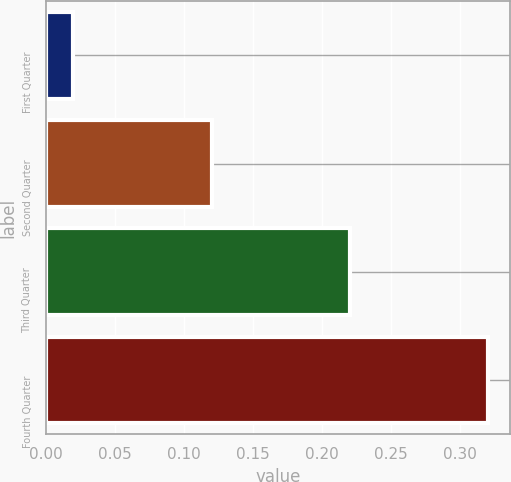Convert chart to OTSL. <chart><loc_0><loc_0><loc_500><loc_500><bar_chart><fcel>First Quarter<fcel>Second Quarter<fcel>Third Quarter<fcel>Fourth Quarter<nl><fcel>0.02<fcel>0.12<fcel>0.22<fcel>0.32<nl></chart> 